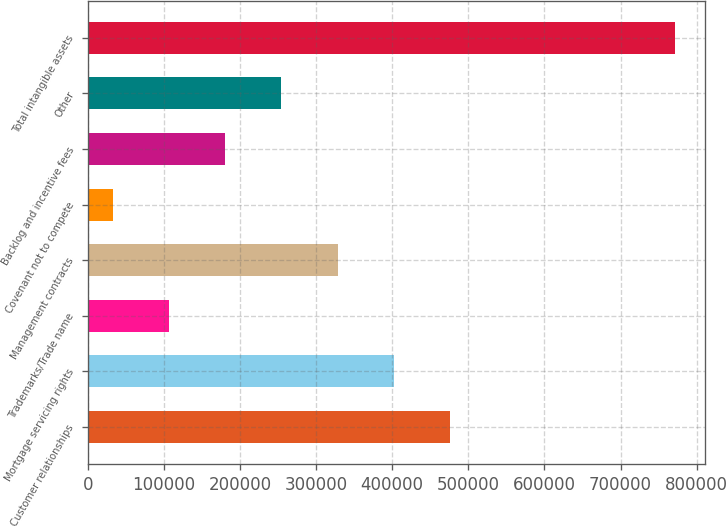<chart> <loc_0><loc_0><loc_500><loc_500><bar_chart><fcel>Customer relationships<fcel>Mortgage servicing rights<fcel>Trademarks/Trade name<fcel>Management contracts<fcel>Covenant not to compete<fcel>Backlog and incentive fees<fcel>Other<fcel>Total intangible assets<nl><fcel>476115<fcel>402225<fcel>106667<fcel>328335<fcel>32777<fcel>180556<fcel>254446<fcel>771673<nl></chart> 